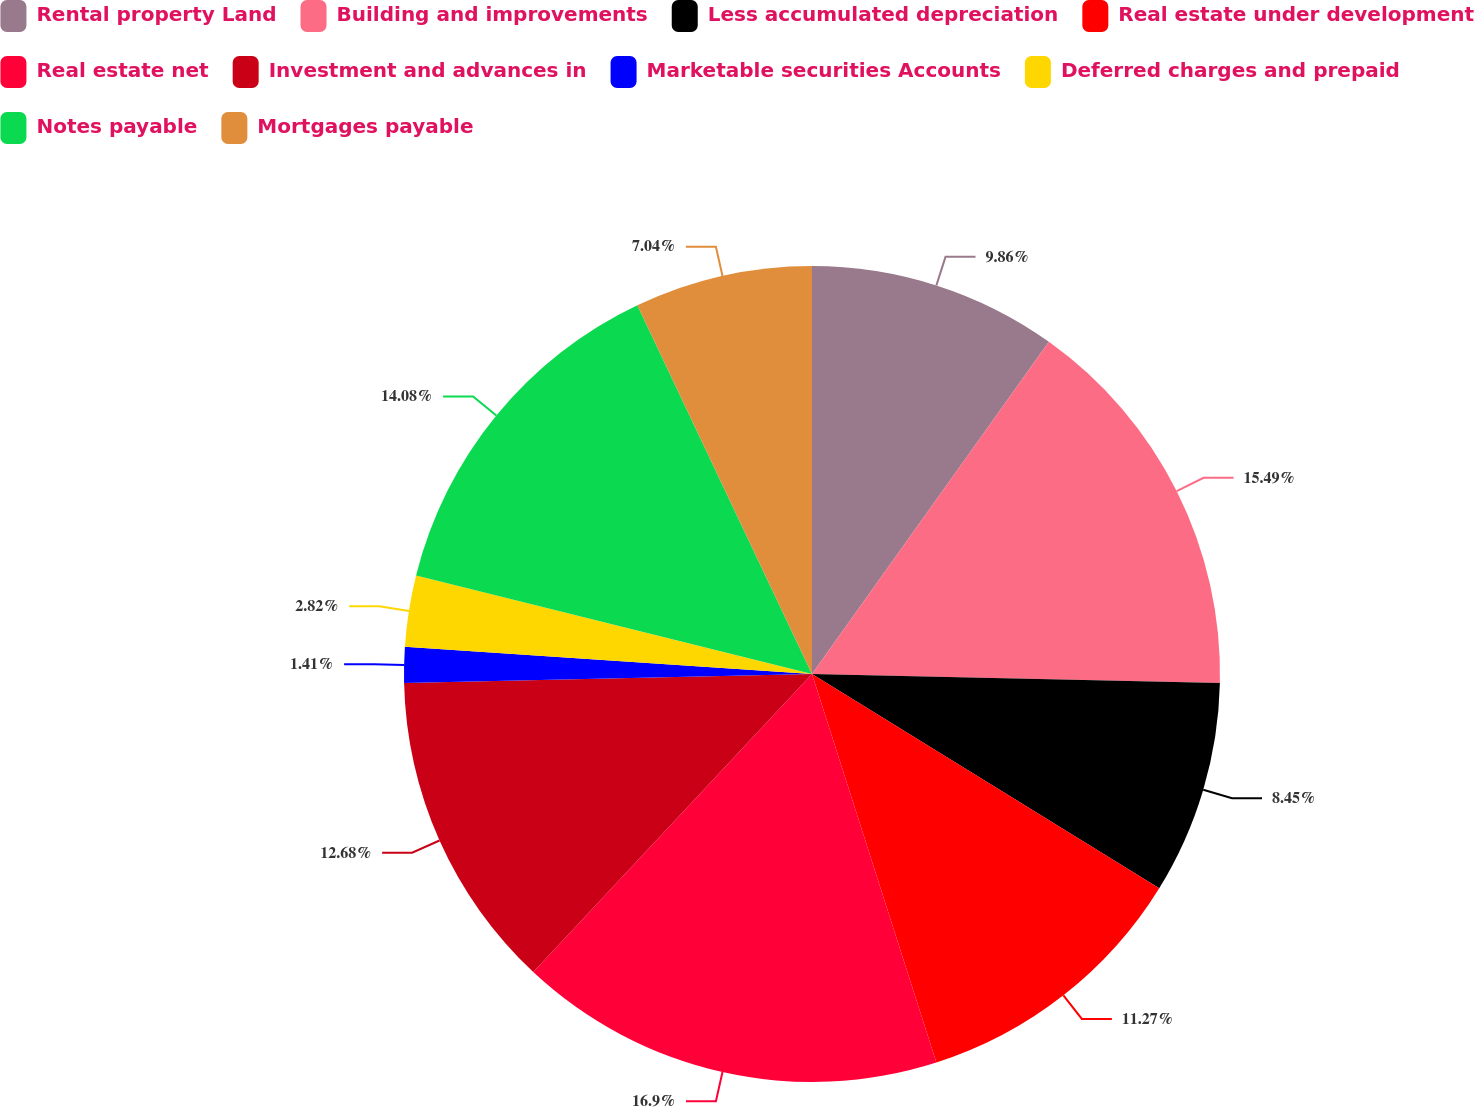Convert chart to OTSL. <chart><loc_0><loc_0><loc_500><loc_500><pie_chart><fcel>Rental property Land<fcel>Building and improvements<fcel>Less accumulated depreciation<fcel>Real estate under development<fcel>Real estate net<fcel>Investment and advances in<fcel>Marketable securities Accounts<fcel>Deferred charges and prepaid<fcel>Notes payable<fcel>Mortgages payable<nl><fcel>9.86%<fcel>15.49%<fcel>8.45%<fcel>11.27%<fcel>16.9%<fcel>12.68%<fcel>1.41%<fcel>2.82%<fcel>14.08%<fcel>7.04%<nl></chart> 